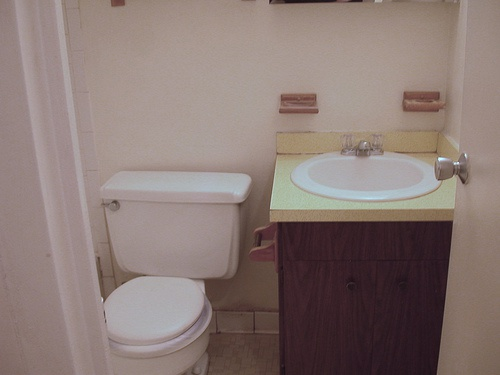Describe the objects in this image and their specific colors. I can see toilet in gray and darkgray tones and sink in gray, darkgray, and lightblue tones in this image. 